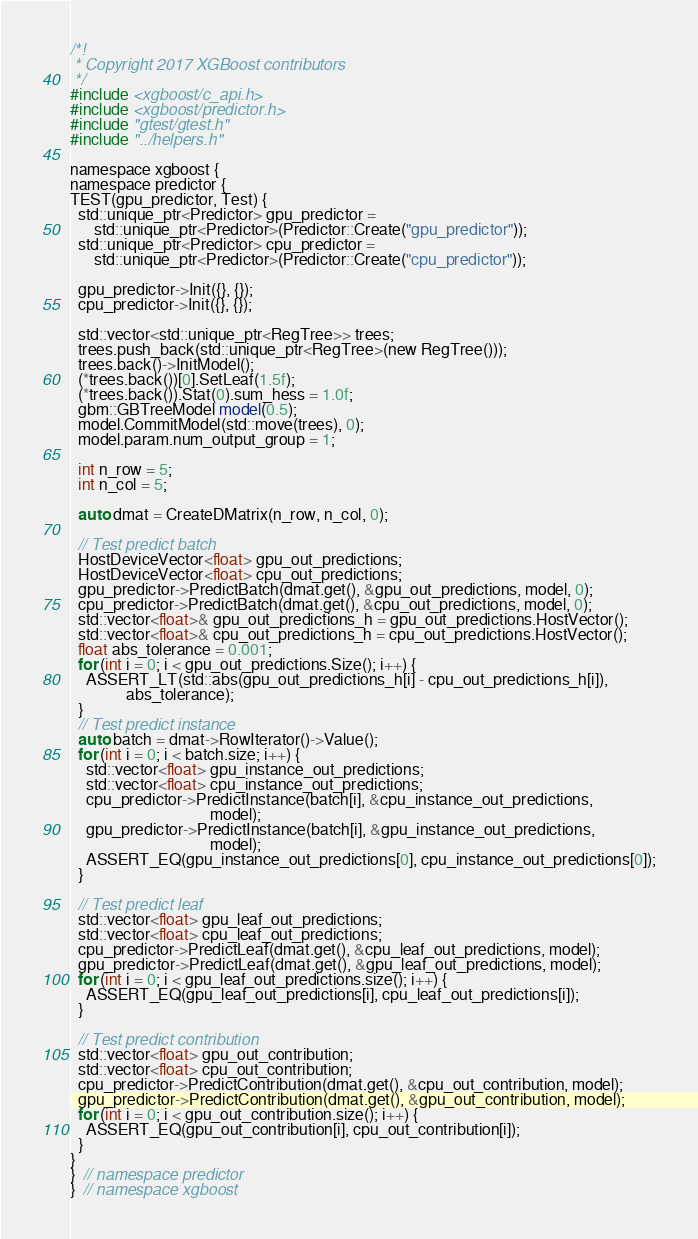<code> <loc_0><loc_0><loc_500><loc_500><_Cuda_>
/*!
 * Copyright 2017 XGBoost contributors
 */
#include <xgboost/c_api.h>
#include <xgboost/predictor.h>
#include "gtest/gtest.h"
#include "../helpers.h"

namespace xgboost {
namespace predictor {
TEST(gpu_predictor, Test) {
  std::unique_ptr<Predictor> gpu_predictor =
      std::unique_ptr<Predictor>(Predictor::Create("gpu_predictor"));
  std::unique_ptr<Predictor> cpu_predictor =
      std::unique_ptr<Predictor>(Predictor::Create("cpu_predictor"));

  gpu_predictor->Init({}, {});
  cpu_predictor->Init({}, {});

  std::vector<std::unique_ptr<RegTree>> trees;
  trees.push_back(std::unique_ptr<RegTree>(new RegTree()));
  trees.back()->InitModel();
  (*trees.back())[0].SetLeaf(1.5f);
  (*trees.back()).Stat(0).sum_hess = 1.0f;
  gbm::GBTreeModel model(0.5);
  model.CommitModel(std::move(trees), 0);
  model.param.num_output_group = 1;

  int n_row = 5;
  int n_col = 5;

  auto dmat = CreateDMatrix(n_row, n_col, 0);

  // Test predict batch
  HostDeviceVector<float> gpu_out_predictions;
  HostDeviceVector<float> cpu_out_predictions;
  gpu_predictor->PredictBatch(dmat.get(), &gpu_out_predictions, model, 0);
  cpu_predictor->PredictBatch(dmat.get(), &cpu_out_predictions, model, 0);
  std::vector<float>& gpu_out_predictions_h = gpu_out_predictions.HostVector();
  std::vector<float>& cpu_out_predictions_h = cpu_out_predictions.HostVector();
  float abs_tolerance = 0.001;
  for (int i = 0; i < gpu_out_predictions.Size(); i++) {
    ASSERT_LT(std::abs(gpu_out_predictions_h[i] - cpu_out_predictions_h[i]),
              abs_tolerance);
  }
  // Test predict instance
  auto batch = dmat->RowIterator()->Value();
  for (int i = 0; i < batch.size; i++) {
    std::vector<float> gpu_instance_out_predictions;
    std::vector<float> cpu_instance_out_predictions;
    cpu_predictor->PredictInstance(batch[i], &cpu_instance_out_predictions,
                                   model);
    gpu_predictor->PredictInstance(batch[i], &gpu_instance_out_predictions,
                                   model);
    ASSERT_EQ(gpu_instance_out_predictions[0], cpu_instance_out_predictions[0]);
  }

  // Test predict leaf
  std::vector<float> gpu_leaf_out_predictions;
  std::vector<float> cpu_leaf_out_predictions;
  cpu_predictor->PredictLeaf(dmat.get(), &cpu_leaf_out_predictions, model);
  gpu_predictor->PredictLeaf(dmat.get(), &gpu_leaf_out_predictions, model);
  for (int i = 0; i < gpu_leaf_out_predictions.size(); i++) {
    ASSERT_EQ(gpu_leaf_out_predictions[i], cpu_leaf_out_predictions[i]);
  }

  // Test predict contribution
  std::vector<float> gpu_out_contribution;
  std::vector<float> cpu_out_contribution;
  cpu_predictor->PredictContribution(dmat.get(), &cpu_out_contribution, model);
  gpu_predictor->PredictContribution(dmat.get(), &gpu_out_contribution, model);
  for (int i = 0; i < gpu_out_contribution.size(); i++) {
    ASSERT_EQ(gpu_out_contribution[i], cpu_out_contribution[i]);
  }
}
}  // namespace predictor
}  // namespace xgboost
</code> 